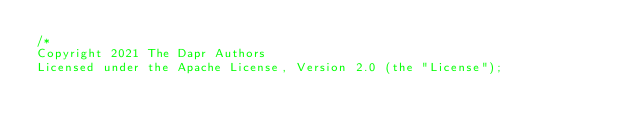Convert code to text. <code><loc_0><loc_0><loc_500><loc_500><_Go_>/*
Copyright 2021 The Dapr Authors
Licensed under the Apache License, Version 2.0 (the "License");</code> 